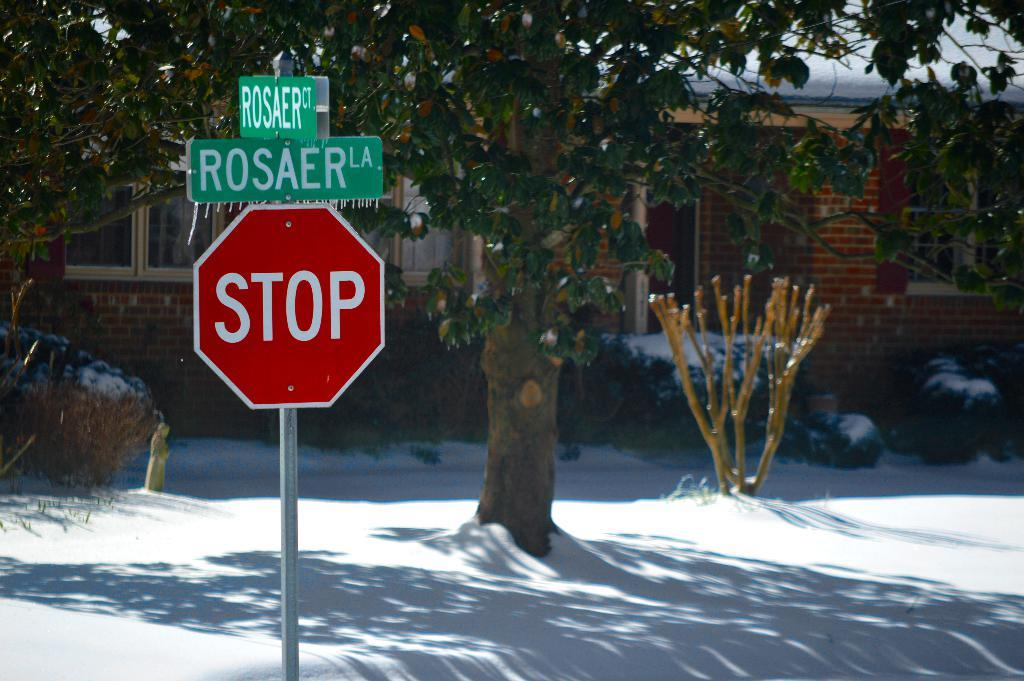Provide a one-sentence caption for the provided image. A stop sign is  on Rosaer street in front of a house. 